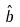<formula> <loc_0><loc_0><loc_500><loc_500>\hat { b }</formula> 